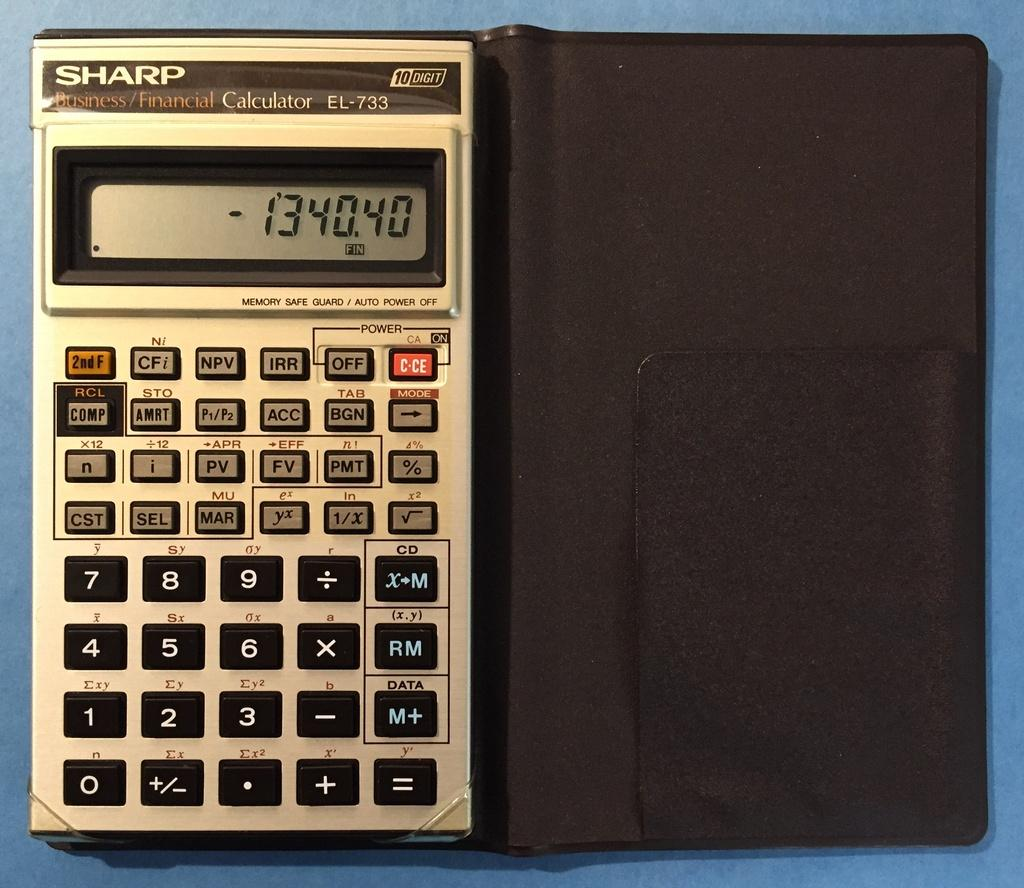<image>
Provide a brief description of the given image. A Sharp brand Business/Financial calculator in a black case with the numbers 134040 displayed on the screen 